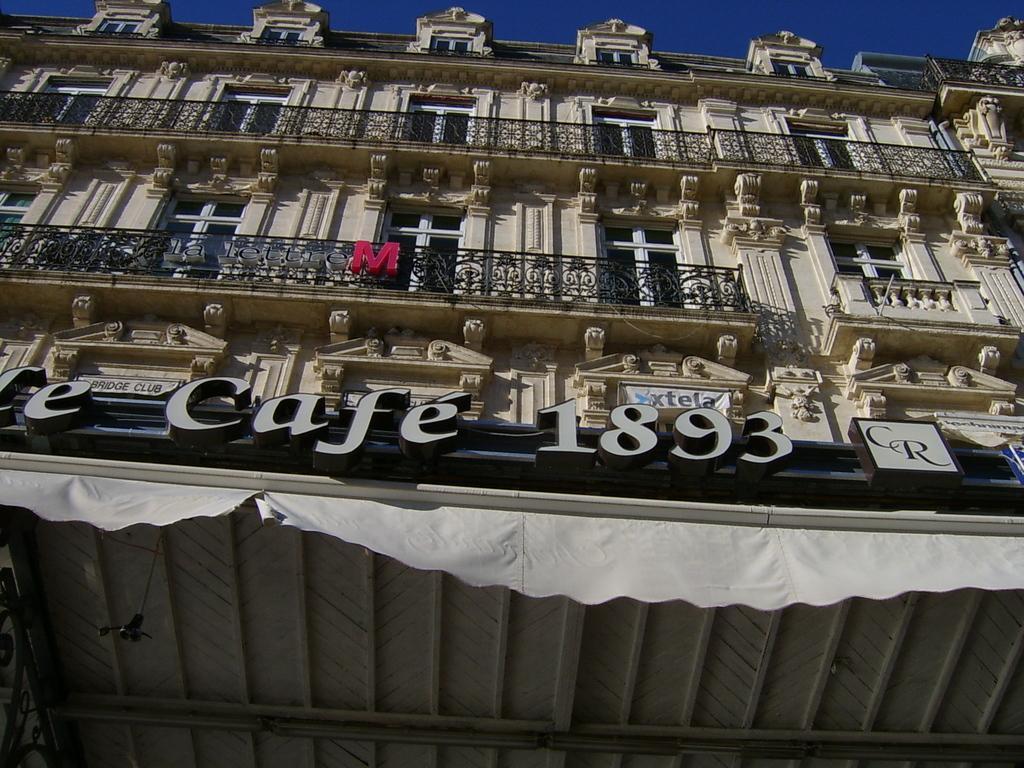In one or two sentences, can you explain what this image depicts? In this image I see a building and I see the railing and I see many windows and I see words and numbers written over here and I see the cream color cloth over here and in the background I see the blue sky. 